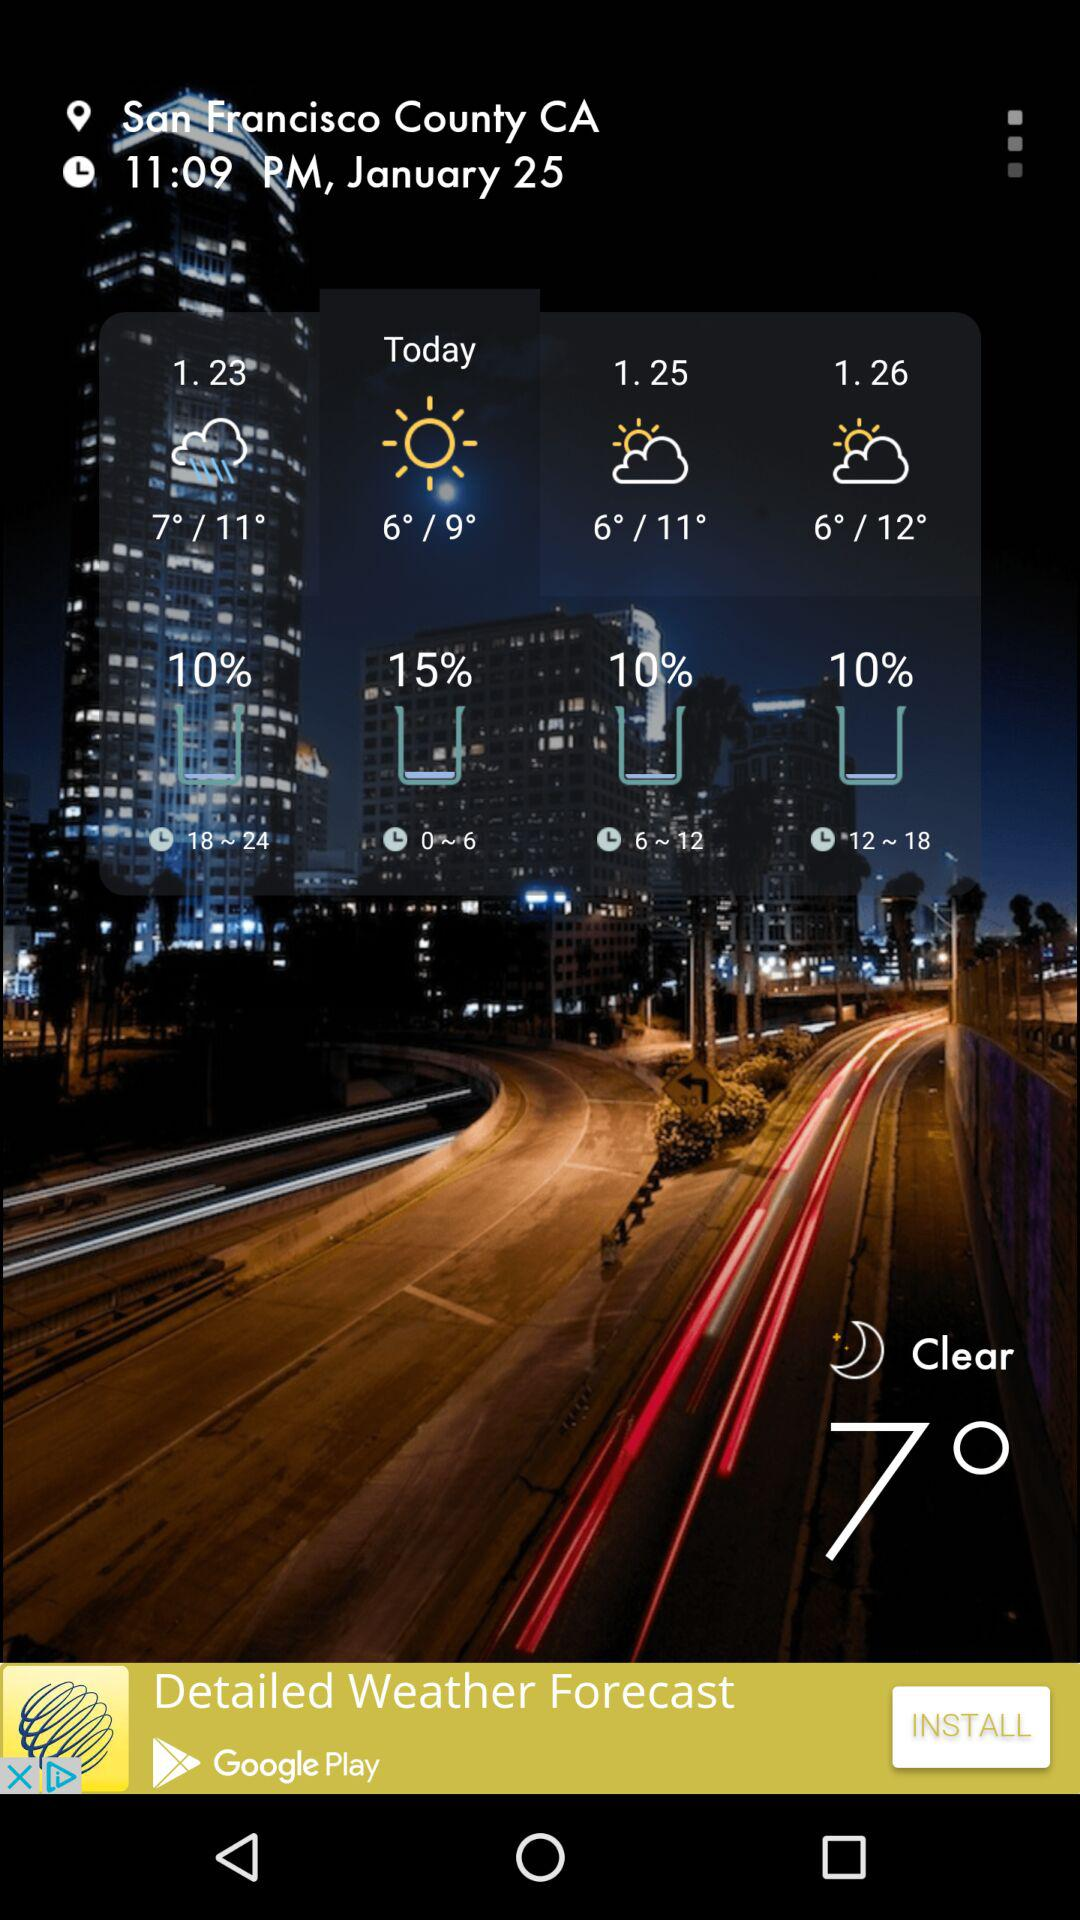What is the location? The location is San Francisco County, CA. 